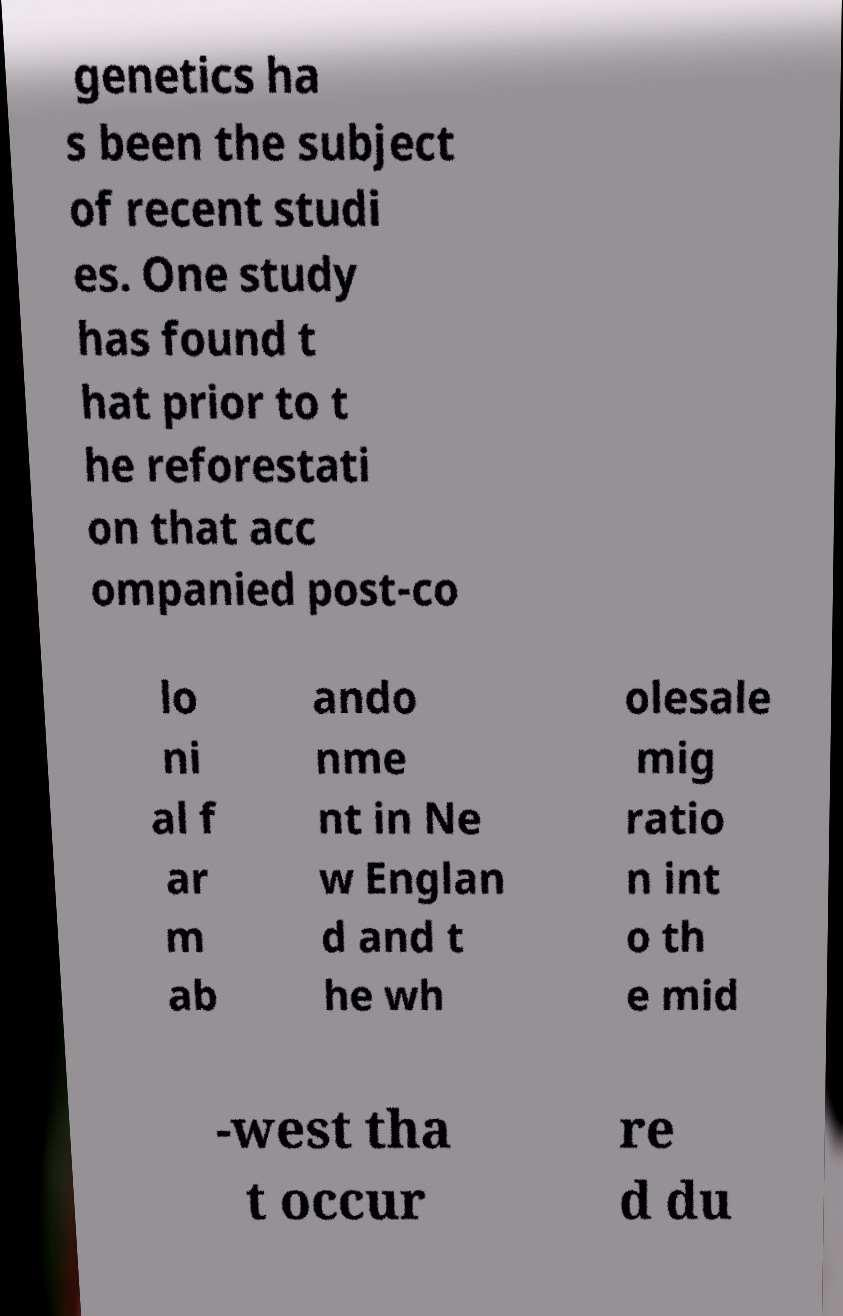There's text embedded in this image that I need extracted. Can you transcribe it verbatim? genetics ha s been the subject of recent studi es. One study has found t hat prior to t he reforestati on that acc ompanied post-co lo ni al f ar m ab ando nme nt in Ne w Englan d and t he wh olesale mig ratio n int o th e mid -west tha t occur re d du 